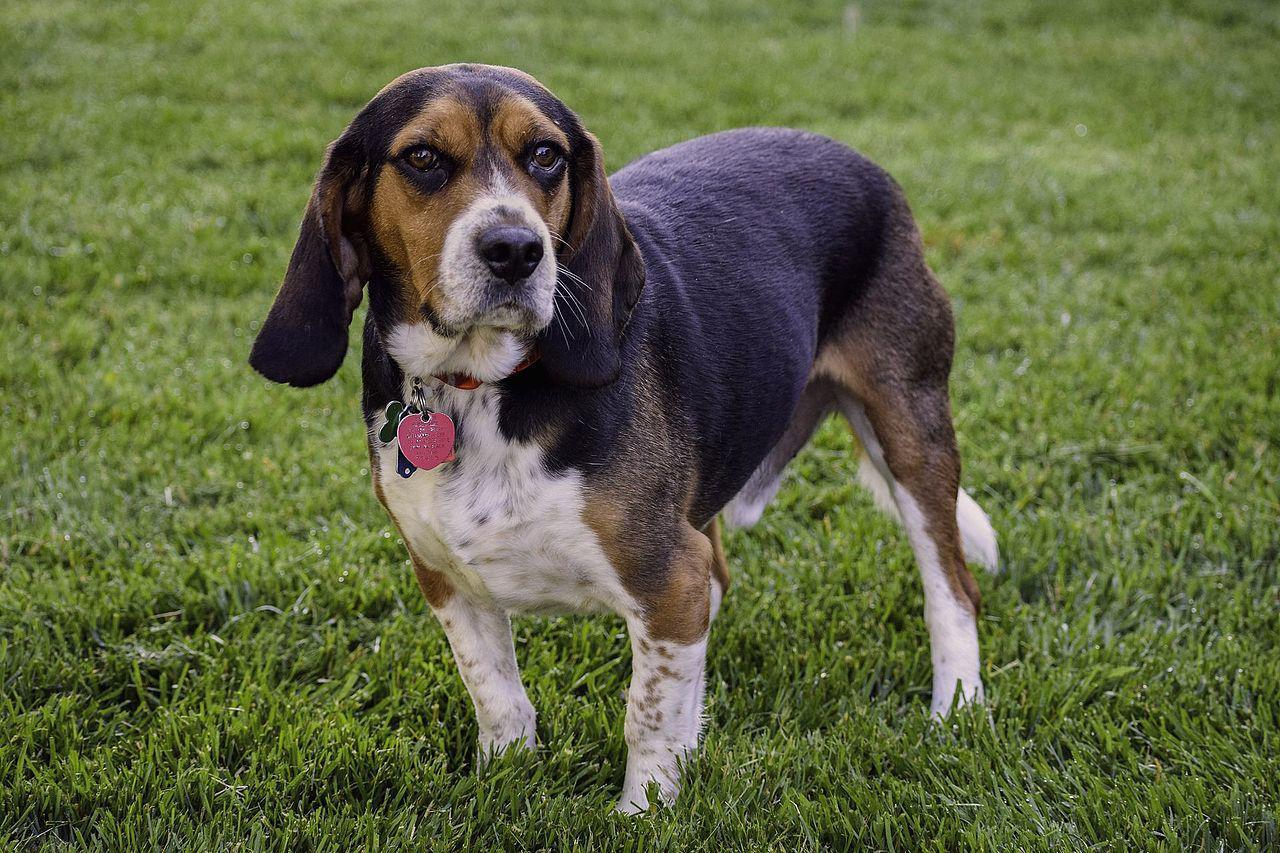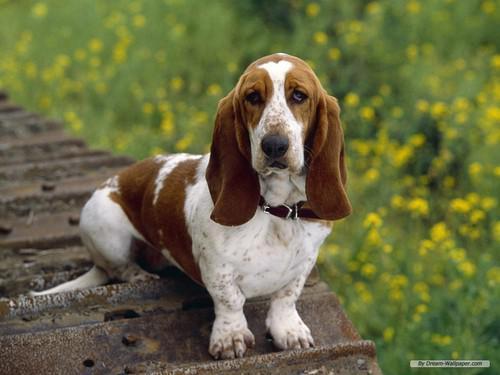The first image is the image on the left, the second image is the image on the right. Examine the images to the left and right. Is the description "Multiple beagle dogs are posed with a rectangular wooden structure, in one image." accurate? Answer yes or no. No. The first image is the image on the left, the second image is the image on the right. Examine the images to the left and right. Is the description "There are more than seven dogs." accurate? Answer yes or no. No. 